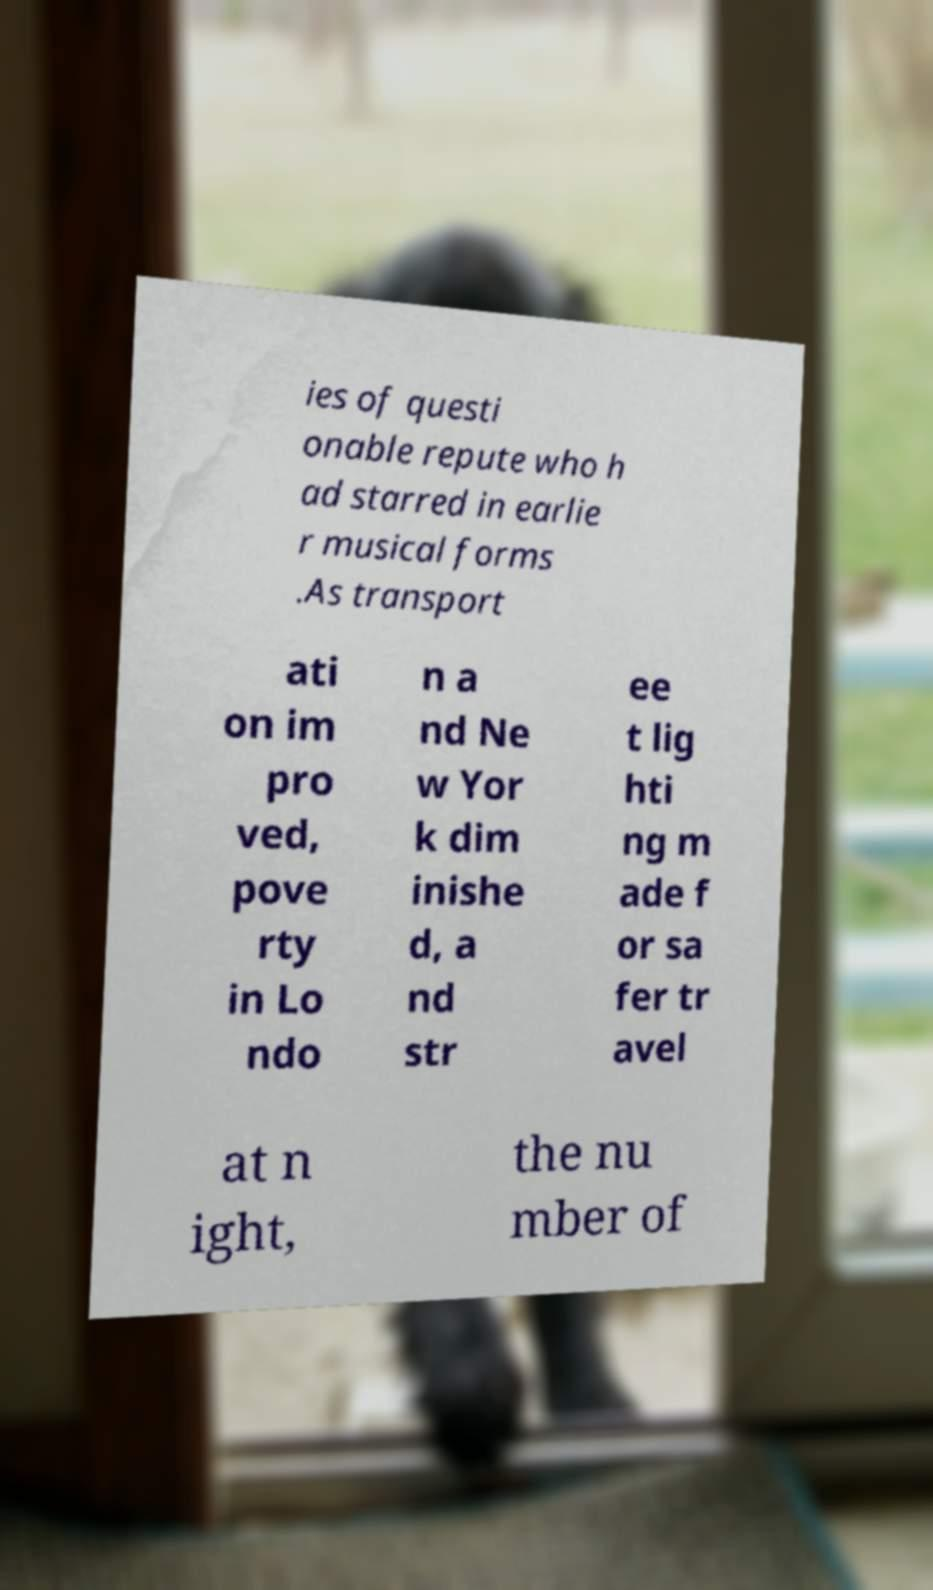Could you assist in decoding the text presented in this image and type it out clearly? ies of questi onable repute who h ad starred in earlie r musical forms .As transport ati on im pro ved, pove rty in Lo ndo n a nd Ne w Yor k dim inishe d, a nd str ee t lig hti ng m ade f or sa fer tr avel at n ight, the nu mber of 